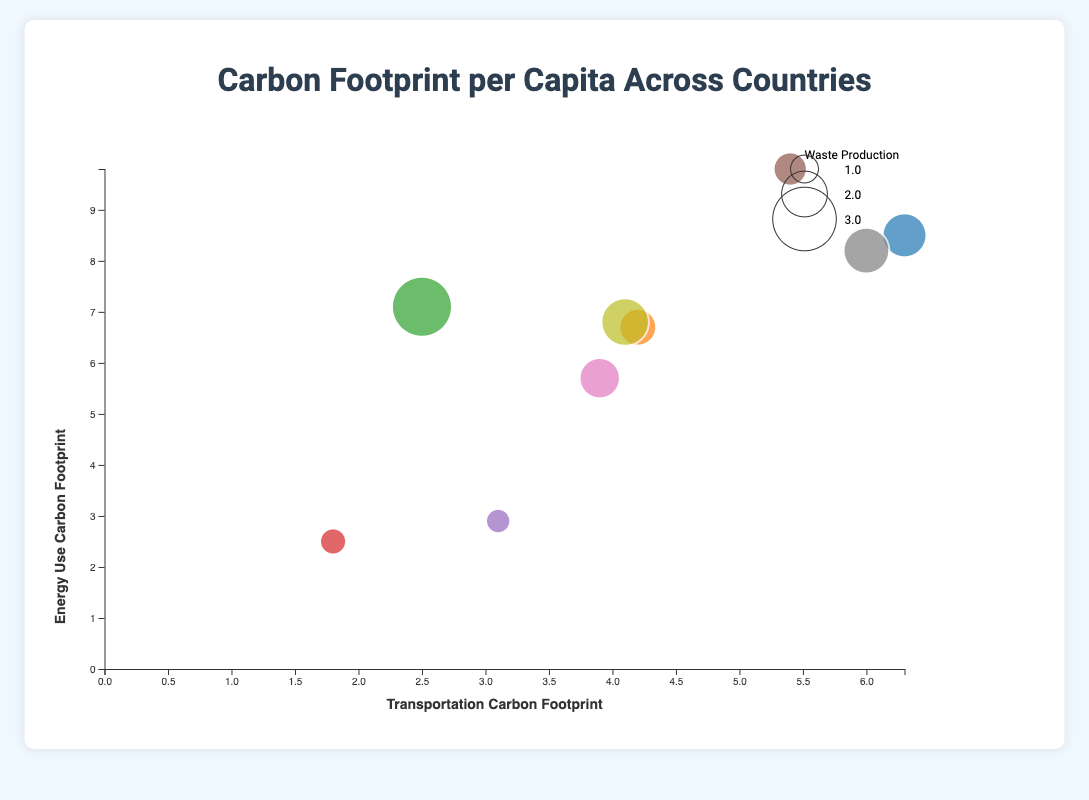What is the title of the chart? The title is displayed at the top of the chart, indicating the main subject of the visualization. It reads "Carbon Footprint per Capita Across Countries".
Answer: Carbon Footprint per Capita Across Countries What is the range of the x-axis and what does it represent? The x-axis ranges from 0 to about 7 and represents the transportation carbon footprint in each country. The axis annotation is at the bottom of the chart displaying "Transportation Carbon Footprint".
Answer: 0 to about 7, Transportation Carbon Footprint Which country has the highest energy use carbon footprint? By examining the y-axis, which represents energy use carbon footprint, Australia is positioned the highest on the y-axis with a value of 9.8.
Answer: Australia What is the radius of the bubble for India, and what does it represent? The radius of the bubble corresponds to the waste production carbon footprint. India's waste production is 0.9, which translates to the smallest bubble size shown.
Answer: Smallest radius, 0.9 How does the transportation carbon footprint of Brazil compare to that of the United Kingdom? Comparing the position along the x-axis (representing transportation carbon footprint), Brazil is at 3.1 while the United Kingdom is at 3.9. Thus, Brazil has a lower transportation carbon footprint.
Answer: Brazil's footprint is lower than the UK's Which country has the largest waste production carbon footprint? By looking at the size of the bubbles, China has the largest bubble indicating the highest waste production carbon footprint of 2.8.
Answer: China What is the average energy use carbon footprint of Canada and Japan? Canada’s energy use is 8.2 and Japan’s is 6.8. Calculate the average by summing these values and dividing by 2: (8.2 + 6.8) / 2 = 15 / 2 = 7.5.
Answer: 7.5 Which country has a higher transportation carbon footprint: Germany or Japan? By comparing their positions along the x-axis, Germany is at 4.2 and Japan is at 4.1. Germany has a higher transportation carbon footprint.
Answer: Germany What is the total waste production carbon footprint of the United States and Canada combined? The waste production for the United States is 1.9 and for Canada is 2.0. Summing these values: 1.9 + 2.0 = 3.9.
Answer: 3.9 Which country has a higher energy use carbon footprint: United Kingdom or Germany? By comparing their positions on the y-axis, the United Kingdom is at 5.7 and Germany is at 6.7. Germany has a higher energy use carbon footprint.
Answer: Germany 